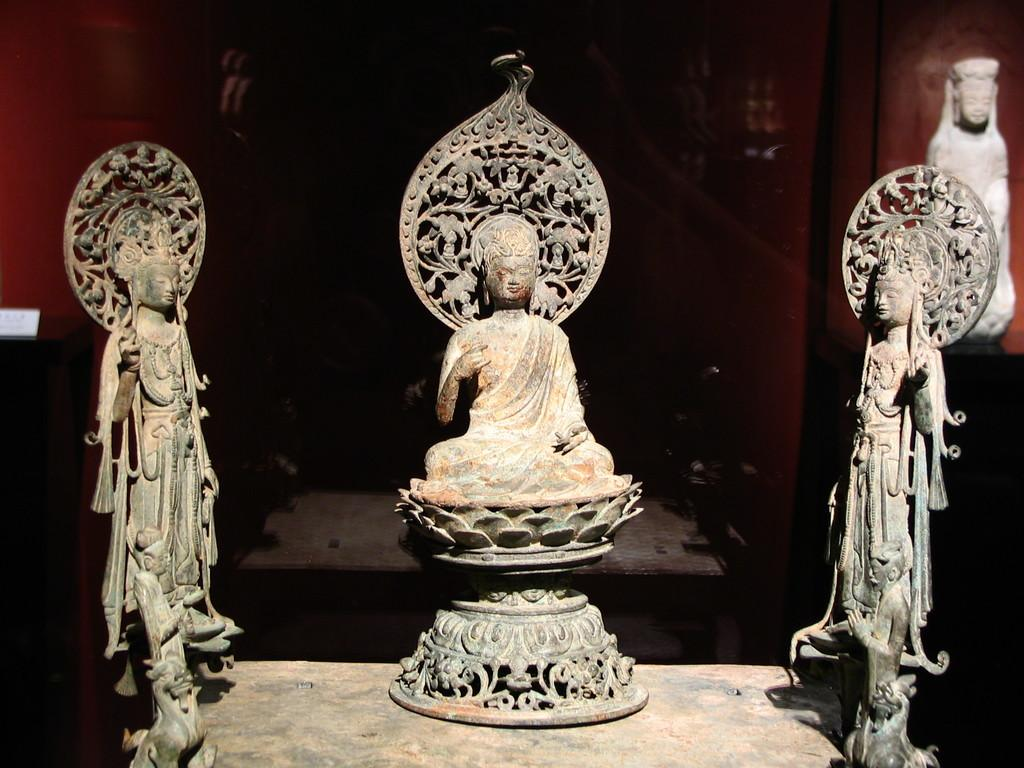What type of art is present in the image? There are sculptures in the image. Where are the sculptures located? The sculptures are on the floor. What is behind the sculptures in the image? There is a wall behind the sculptures. How does the wealth of the sculptures affect their connection to the wool in the image? There is no wealth, connection, or wool present in the image; it only features sculptures on the floor with a wall behind them. 